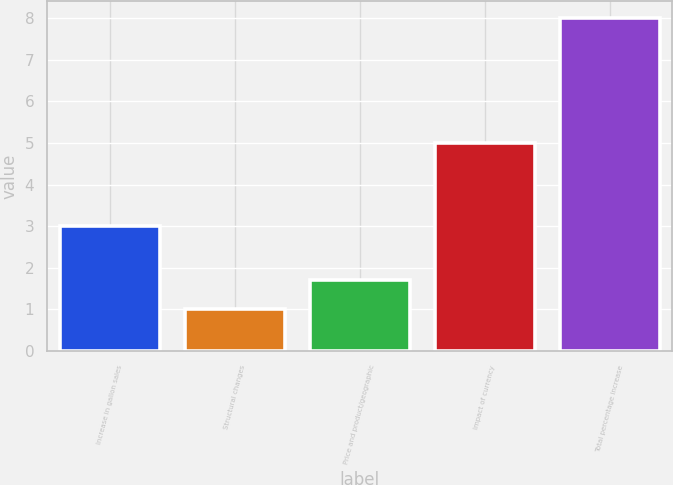<chart> <loc_0><loc_0><loc_500><loc_500><bar_chart><fcel>Increase in gallon sales<fcel>Structural changes<fcel>Price and product/geographic<fcel>Impact of currency<fcel>Total percentage increase<nl><fcel>3<fcel>1<fcel>1.7<fcel>5<fcel>8<nl></chart> 